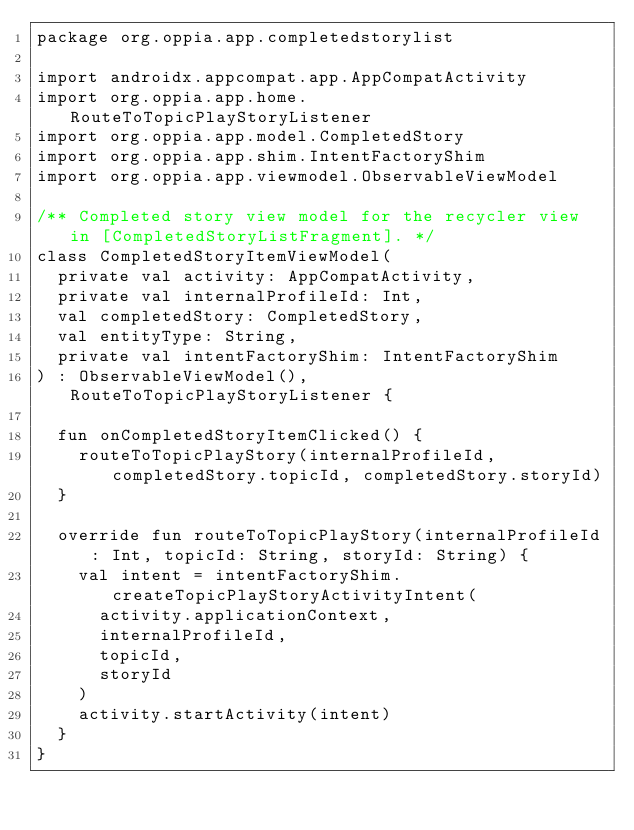<code> <loc_0><loc_0><loc_500><loc_500><_Kotlin_>package org.oppia.app.completedstorylist

import androidx.appcompat.app.AppCompatActivity
import org.oppia.app.home.RouteToTopicPlayStoryListener
import org.oppia.app.model.CompletedStory
import org.oppia.app.shim.IntentFactoryShim
import org.oppia.app.viewmodel.ObservableViewModel

/** Completed story view model for the recycler view in [CompletedStoryListFragment]. */
class CompletedStoryItemViewModel(
  private val activity: AppCompatActivity,
  private val internalProfileId: Int,
  val completedStory: CompletedStory,
  val entityType: String,
  private val intentFactoryShim: IntentFactoryShim
) : ObservableViewModel(), RouteToTopicPlayStoryListener {

  fun onCompletedStoryItemClicked() {
    routeToTopicPlayStory(internalProfileId, completedStory.topicId, completedStory.storyId)
  }

  override fun routeToTopicPlayStory(internalProfileId: Int, topicId: String, storyId: String) {
    val intent = intentFactoryShim.createTopicPlayStoryActivityIntent(
      activity.applicationContext,
      internalProfileId,
      topicId,
      storyId
    )
    activity.startActivity(intent)
  }
}
</code> 